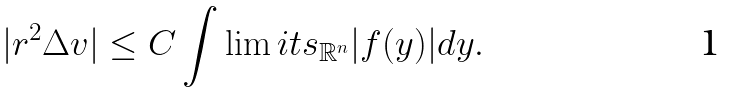<formula> <loc_0><loc_0><loc_500><loc_500>| r ^ { 2 } \Delta v | \leq C \int \lim i t s _ { \mathbb { R } ^ { n } } { | f ( y ) | d y } .</formula> 